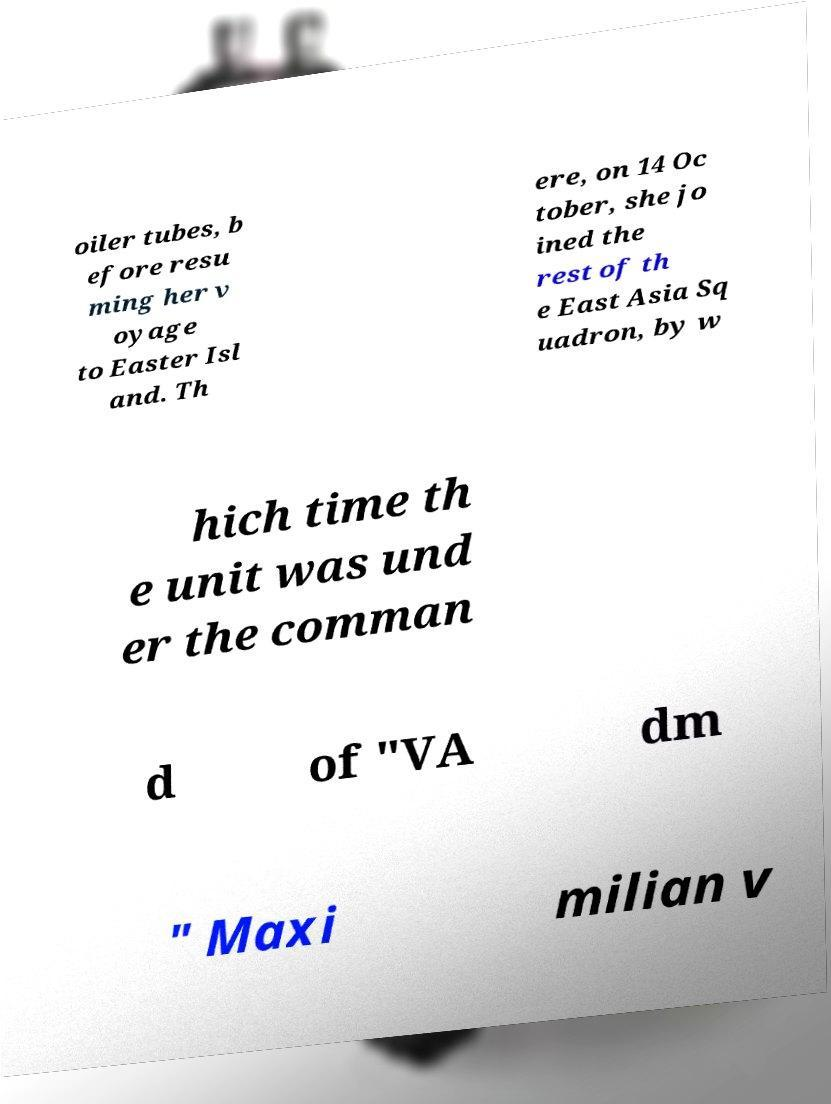Please read and relay the text visible in this image. What does it say? oiler tubes, b efore resu ming her v oyage to Easter Isl and. Th ere, on 14 Oc tober, she jo ined the rest of th e East Asia Sq uadron, by w hich time th e unit was und er the comman d of "VA dm " Maxi milian v 